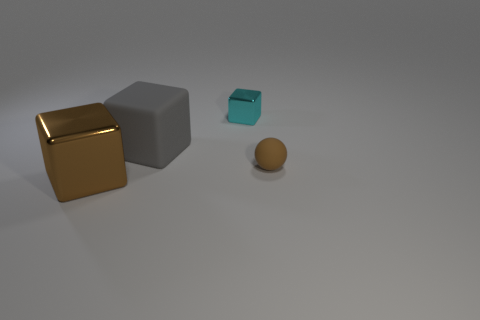Add 3 small cyan metal cubes. How many objects exist? 7 Subtract all cubes. How many objects are left? 1 Subtract 0 purple blocks. How many objects are left? 4 Subtract all brown balls. Subtract all big brown blocks. How many objects are left? 2 Add 3 tiny brown rubber things. How many tiny brown rubber things are left? 4 Add 2 gray rubber things. How many gray rubber things exist? 3 